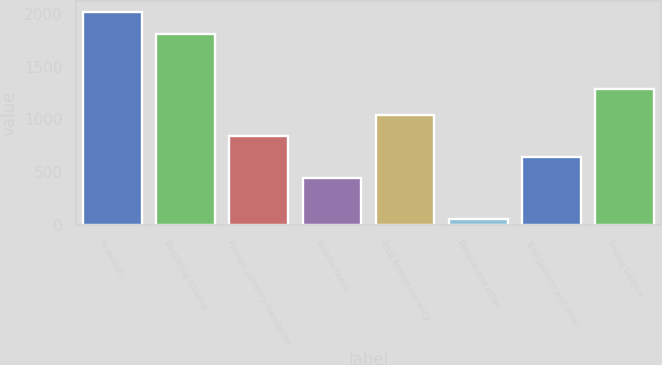Convert chart. <chart><loc_0><loc_0><loc_500><loc_500><bar_chart><fcel>In millions<fcel>Beginning balance<fcel>Foreign currency translation<fcel>Income taxes<fcel>Total foreign currency<fcel>Pension and other<fcel>Total pension and other<fcel>Ending balance<nl><fcel>2017<fcel>1807<fcel>840.4<fcel>448.2<fcel>1036.5<fcel>56<fcel>644.3<fcel>1287<nl></chart> 